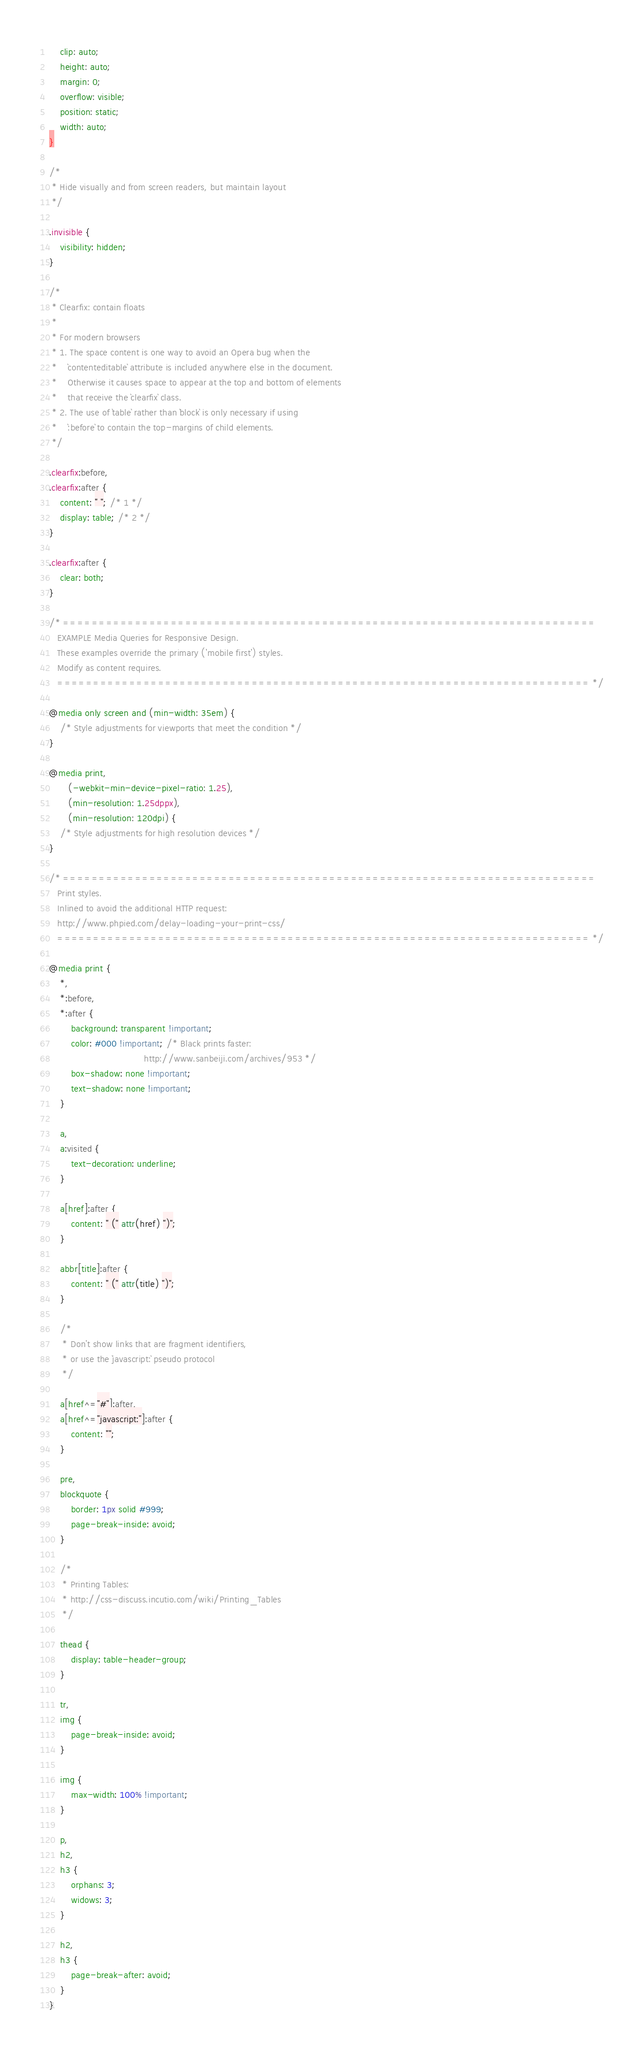Convert code to text. <code><loc_0><loc_0><loc_500><loc_500><_CSS_>    clip: auto;
    height: auto;
    margin: 0;
    overflow: visible;
    position: static;
    width: auto;
}

/*
 * Hide visually and from screen readers, but maintain layout
 */

.invisible {
    visibility: hidden;
}

/*
 * Clearfix: contain floats
 *
 * For modern browsers
 * 1. The space content is one way to avoid an Opera bug when the
 *    `contenteditable` attribute is included anywhere else in the document.
 *    Otherwise it causes space to appear at the top and bottom of elements
 *    that receive the `clearfix` class.
 * 2. The use of `table` rather than `block` is only necessary if using
 *    `:before` to contain the top-margins of child elements.
 */

.clearfix:before,
.clearfix:after {
    content: " "; /* 1 */
    display: table; /* 2 */
}

.clearfix:after {
    clear: both;
}

/* ==========================================================================
   EXAMPLE Media Queries for Responsive Design.
   These examples override the primary ('mobile first') styles.
   Modify as content requires.
   ========================================================================== */

@media only screen and (min-width: 35em) {
    /* Style adjustments for viewports that meet the condition */
}

@media print,
       (-webkit-min-device-pixel-ratio: 1.25),
       (min-resolution: 1.25dppx),
       (min-resolution: 120dpi) {
    /* Style adjustments for high resolution devices */
}

/* ==========================================================================
   Print styles.
   Inlined to avoid the additional HTTP request:
   http://www.phpied.com/delay-loading-your-print-css/
   ========================================================================== */

@media print {
    *,
    *:before,
    *:after {
        background: transparent !important;
        color: #000 !important; /* Black prints faster:
                                   http://www.sanbeiji.com/archives/953 */
        box-shadow: none !important;
        text-shadow: none !important;
    }

    a,
    a:visited {
        text-decoration: underline;
    }

    a[href]:after {
        content: " (" attr(href) ")";
    }

    abbr[title]:after {
        content: " (" attr(title) ")";
    }

    /*
     * Don't show links that are fragment identifiers,
     * or use the `javascript:` pseudo protocol
     */

    a[href^="#"]:after,
    a[href^="javascript:"]:after {
        content: "";
    }

    pre,
    blockquote {
        border: 1px solid #999;
        page-break-inside: avoid;
    }

    /*
     * Printing Tables:
     * http://css-discuss.incutio.com/wiki/Printing_Tables
     */

    thead {
        display: table-header-group;
    }

    tr,
    img {
        page-break-inside: avoid;
    }

    img {
        max-width: 100% !important;
    }

    p,
    h2,
    h3 {
        orphans: 3;
        widows: 3;
    }

    h2,
    h3 {
        page-break-after: avoid;
    }
}
</code> 